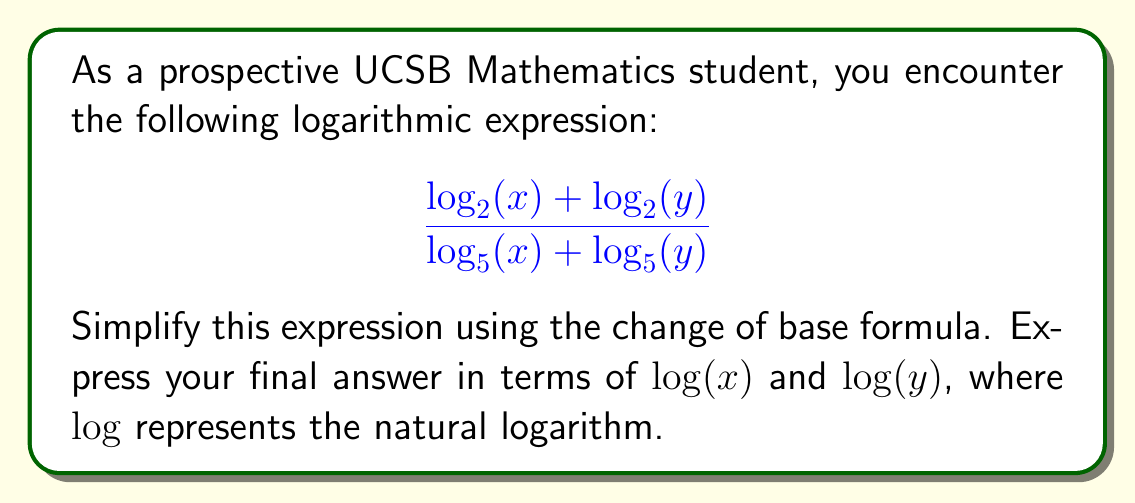What is the answer to this math problem? Let's approach this step-by-step:

1) First, recall the change of base formula:
   For any positive base $a$ and positive number $x$, $\log_a(x) = \frac{\log(x)}{\log(a)}$

2) Apply this to the numerator:
   $\log_2(x) = \frac{\log(x)}{\log(2)}$ and $\log_2(y) = \frac{\log(y)}{\log(2)}$

3) The numerator becomes:
   $$\frac{\log(x)}{\log(2)} + \frac{\log(y)}{\log(2)} = \frac{\log(x) + \log(y)}{\log(2)}$$

4) Similarly for the denominator:
   $\log_5(x) = \frac{\log(x)}{\log(5)}$ and $\log_5(y) = \frac{\log(y)}{\log(5)}$

5) The denominator becomes:
   $$\frac{\log(x)}{\log(5)} + \frac{\log(y)}{\log(5)} = \frac{\log(x) + \log(y)}{\log(5)}$$

6) Now our expression looks like:
   $$\frac{\frac{\log(x) + \log(y)}{\log(2)}}{\frac{\log(x) + \log(y)}{\log(5)}}$$

7) When dividing fractions, we multiply by the reciprocal:
   $$\frac{\log(x) + \log(y)}{\log(2)} \cdot \frac{\log(5)}{\log(x) + \log(y)}$$

8) The $\log(x) + \log(y)$ terms cancel out:
   $$\frac{\log(5)}{\log(2)}$$

This is our simplified expression in terms of natural logarithms.
Answer: $$\frac{\log(5)}{\log(2)}$$ 